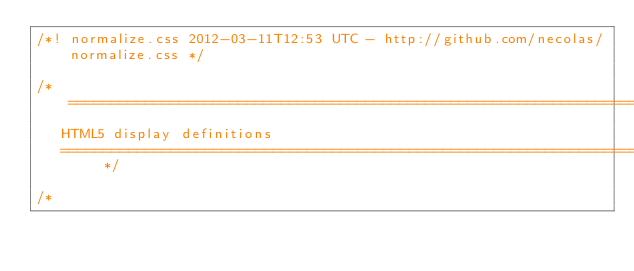<code> <loc_0><loc_0><loc_500><loc_500><_CSS_>/*! normalize.css 2012-03-11T12:53 UTC - http://github.com/necolas/normalize.css */

/* =============================================================================
   HTML5 display definitions
   ========================================================================== */

/*</code> 